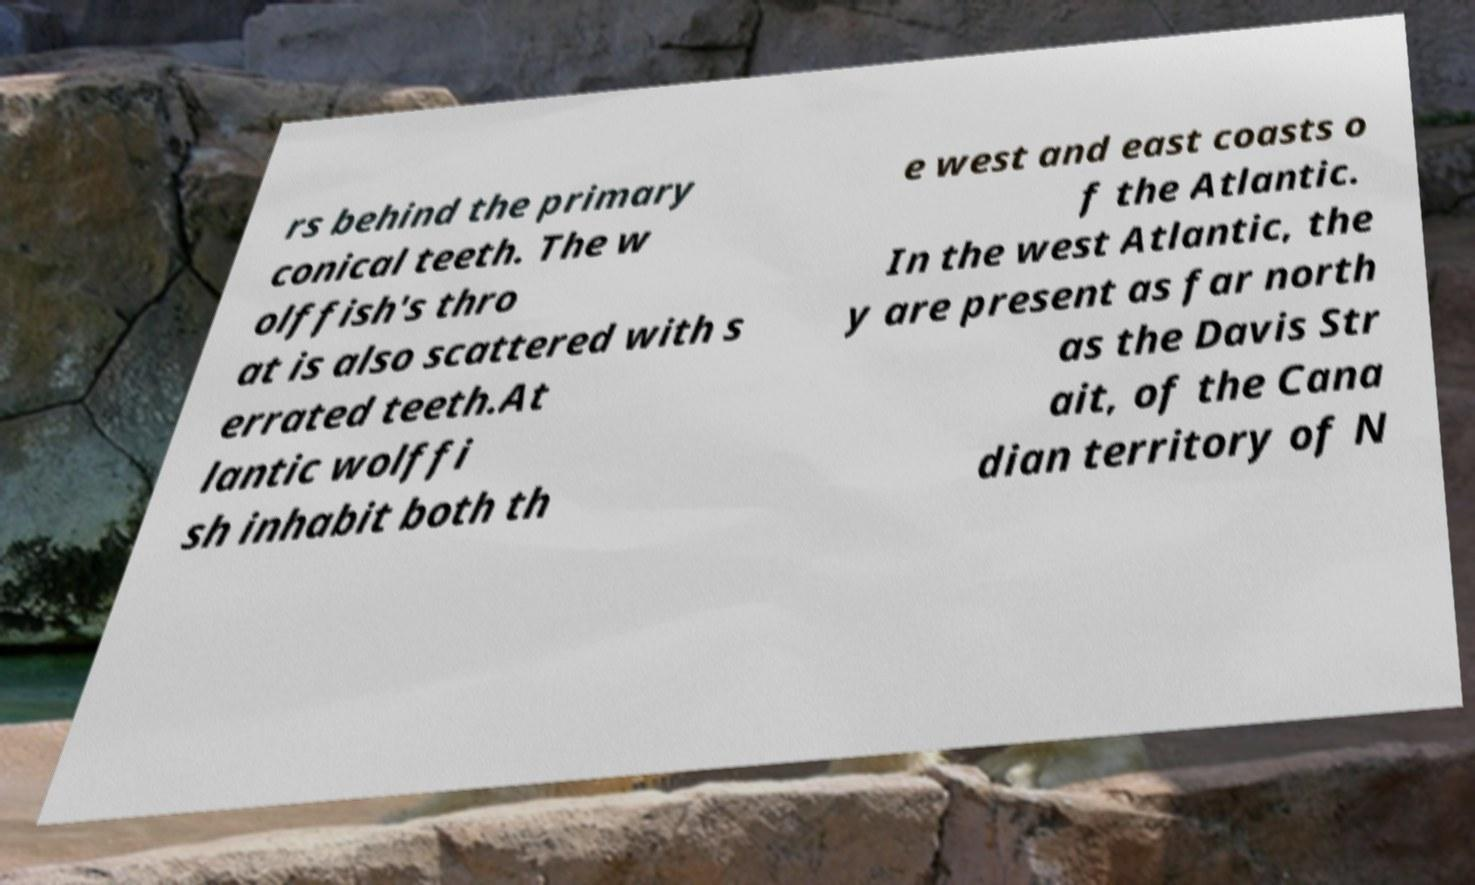Could you assist in decoding the text presented in this image and type it out clearly? rs behind the primary conical teeth. The w olffish's thro at is also scattered with s errated teeth.At lantic wolffi sh inhabit both th e west and east coasts o f the Atlantic. In the west Atlantic, the y are present as far north as the Davis Str ait, of the Cana dian territory of N 